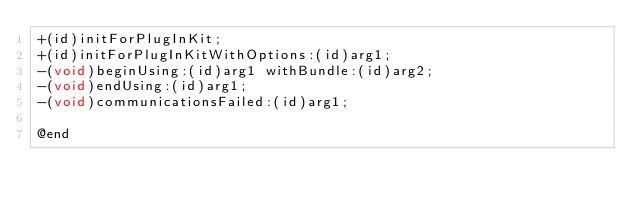Convert code to text. <code><loc_0><loc_0><loc_500><loc_500><_C_>+(id)initForPlugInKit;
+(id)initForPlugInKitWithOptions:(id)arg1;
-(void)beginUsing:(id)arg1 withBundle:(id)arg2;
-(void)endUsing:(id)arg1;
-(void)communicationsFailed:(id)arg1;

@end

</code> 